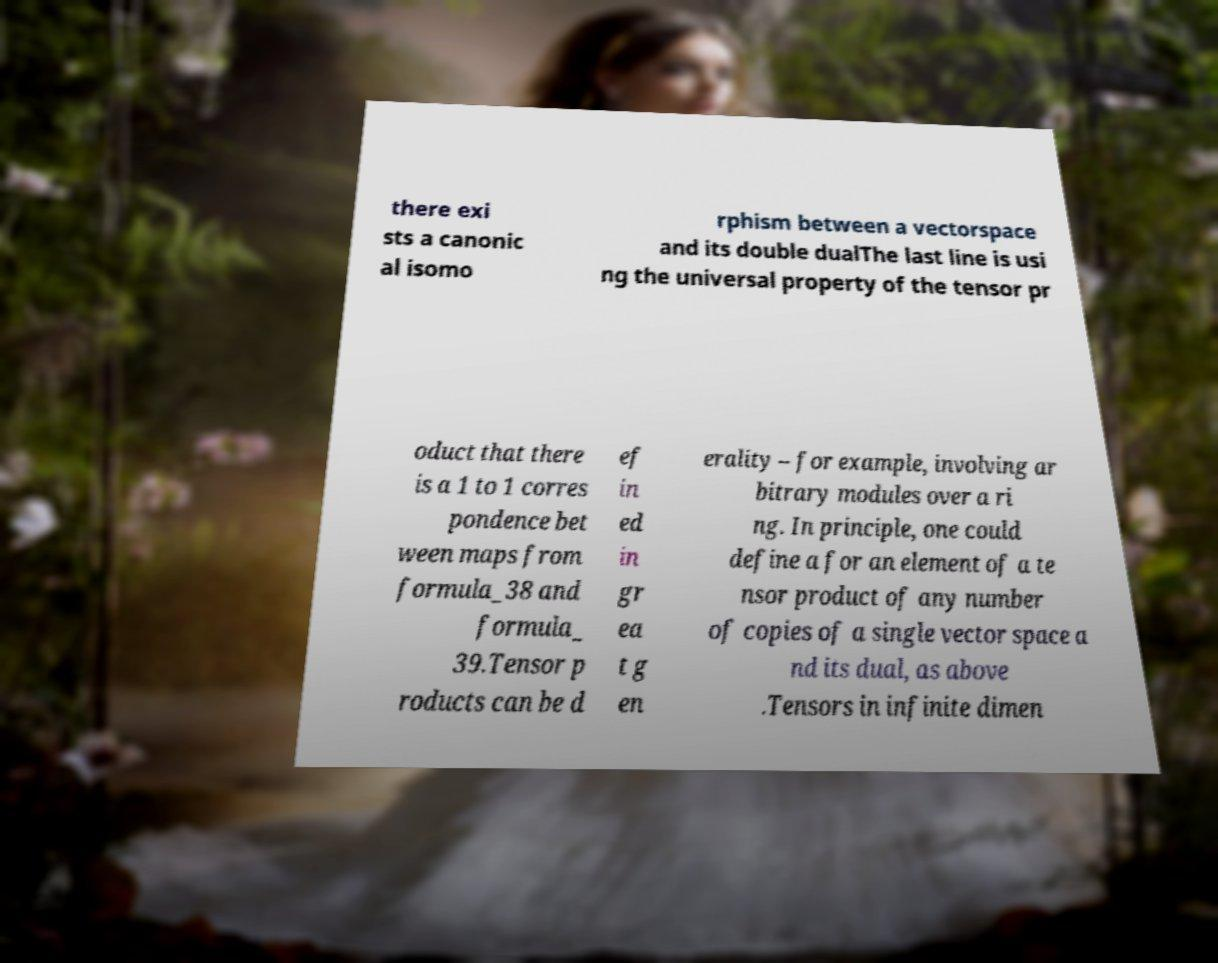Please identify and transcribe the text found in this image. there exi sts a canonic al isomo rphism between a vectorspace and its double dualThe last line is usi ng the universal property of the tensor pr oduct that there is a 1 to 1 corres pondence bet ween maps from formula_38 and formula_ 39.Tensor p roducts can be d ef in ed in gr ea t g en erality – for example, involving ar bitrary modules over a ri ng. In principle, one could define a for an element of a te nsor product of any number of copies of a single vector space a nd its dual, as above .Tensors in infinite dimen 